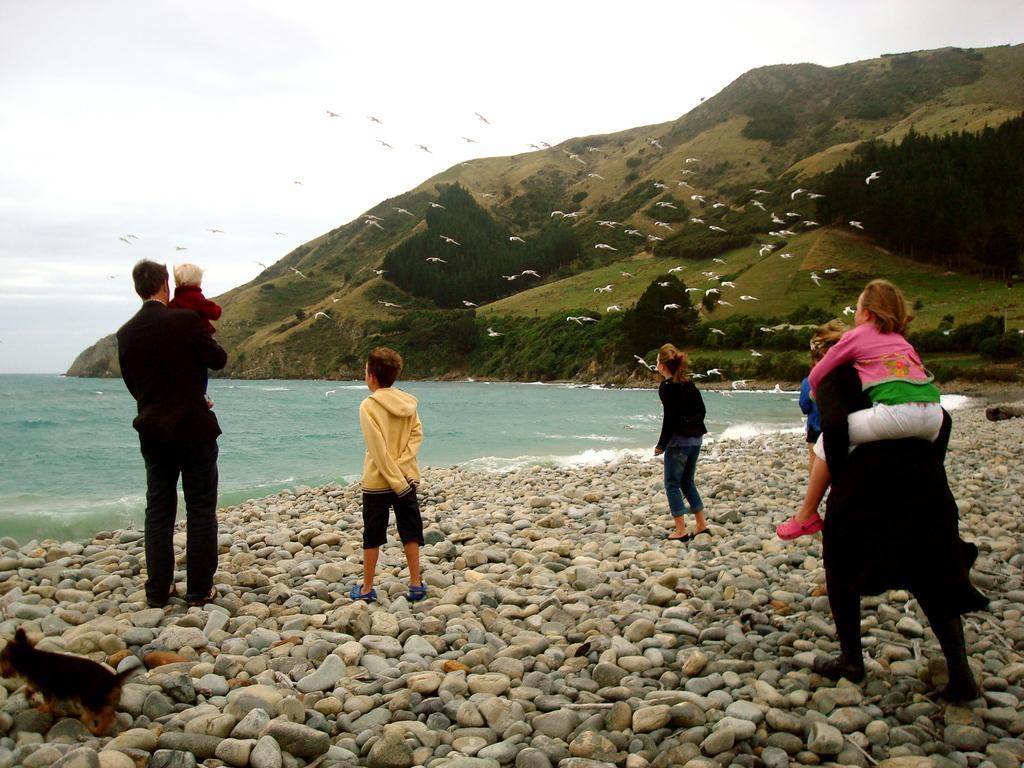In one or two sentences, can you explain what this image depicts? In this image I can see a group of people on stones, flocks of birds and ocean. In the background I can see mountains, grass, animal and the sky. This image is taken may be near the beach. 